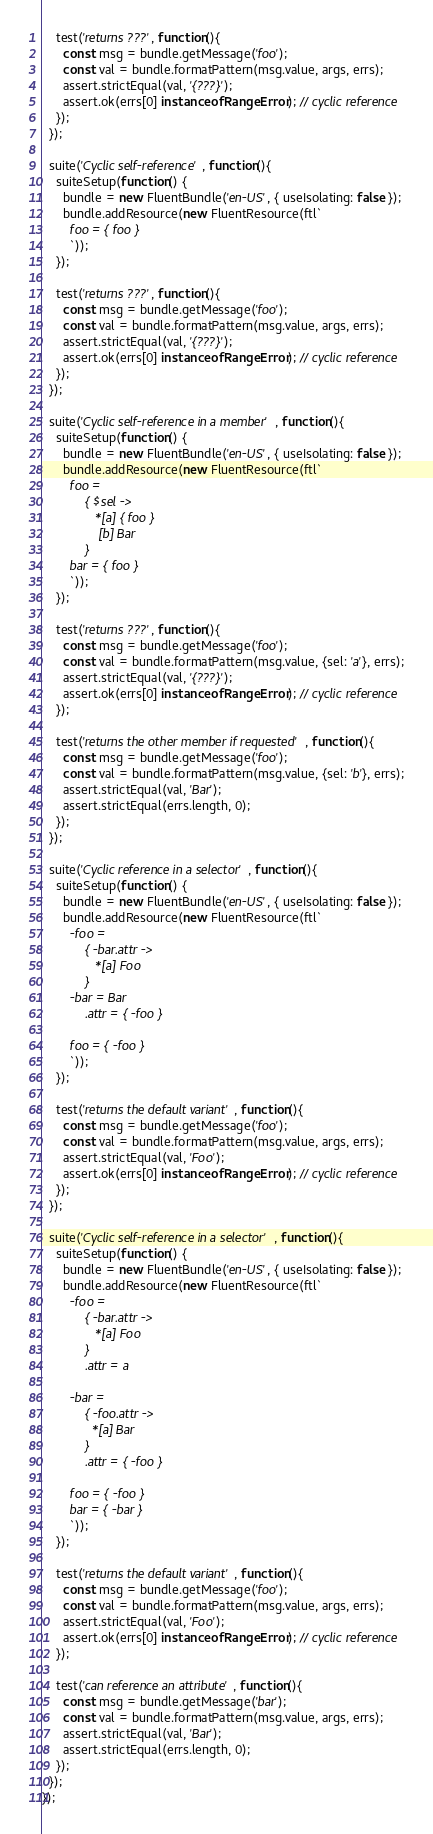<code> <loc_0><loc_0><loc_500><loc_500><_JavaScript_>
    test('returns ???', function(){
      const msg = bundle.getMessage('foo');
      const val = bundle.formatPattern(msg.value, args, errs);
      assert.strictEqual(val, '{???}');
      assert.ok(errs[0] instanceof RangeError); // cyclic reference
    });
  });

  suite('Cyclic self-reference', function(){
    suiteSetup(function() {
      bundle = new FluentBundle('en-US', { useIsolating: false });
      bundle.addResource(new FluentResource(ftl`
        foo = { foo }
        `));
    });

    test('returns ???', function(){
      const msg = bundle.getMessage('foo');
      const val = bundle.formatPattern(msg.value, args, errs);
      assert.strictEqual(val, '{???}');
      assert.ok(errs[0] instanceof RangeError); // cyclic reference
    });
  });

  suite('Cyclic self-reference in a member', function(){
    suiteSetup(function() {
      bundle = new FluentBundle('en-US', { useIsolating: false });
      bundle.addResource(new FluentResource(ftl`
        foo =
            { $sel ->
               *[a] { foo }
                [b] Bar
            }
        bar = { foo }
        `));
    });

    test('returns ???', function(){
      const msg = bundle.getMessage('foo');
      const val = bundle.formatPattern(msg.value, {sel: 'a'}, errs);
      assert.strictEqual(val, '{???}');
      assert.ok(errs[0] instanceof RangeError); // cyclic reference
    });

    test('returns the other member if requested', function(){
      const msg = bundle.getMessage('foo');
      const val = bundle.formatPattern(msg.value, {sel: 'b'}, errs);
      assert.strictEqual(val, 'Bar');
      assert.strictEqual(errs.length, 0);
    });
  });

  suite('Cyclic reference in a selector', function(){
    suiteSetup(function() {
      bundle = new FluentBundle('en-US', { useIsolating: false });
      bundle.addResource(new FluentResource(ftl`
        -foo =
            { -bar.attr ->
               *[a] Foo
            }
        -bar = Bar
            .attr = { -foo }

        foo = { -foo }
        `));
    });

    test('returns the default variant', function(){
      const msg = bundle.getMessage('foo');
      const val = bundle.formatPattern(msg.value, args, errs);
      assert.strictEqual(val, 'Foo');
      assert.ok(errs[0] instanceof RangeError); // cyclic reference
    });
  });

  suite('Cyclic self-reference in a selector', function(){
    suiteSetup(function() {
      bundle = new FluentBundle('en-US', { useIsolating: false });
      bundle.addResource(new FluentResource(ftl`
        -foo =
            { -bar.attr ->
               *[a] Foo
            }
            .attr = a

        -bar =
            { -foo.attr ->
              *[a] Bar
            }
            .attr = { -foo }

        foo = { -foo }
        bar = { -bar }
        `));
    });

    test('returns the default variant', function(){
      const msg = bundle.getMessage('foo');
      const val = bundle.formatPattern(msg.value, args, errs);
      assert.strictEqual(val, 'Foo');
      assert.ok(errs[0] instanceof RangeError); // cyclic reference
    });

    test('can reference an attribute', function(){
      const msg = bundle.getMessage('bar');
      const val = bundle.formatPattern(msg.value, args, errs);
      assert.strictEqual(val, 'Bar');
      assert.strictEqual(errs.length, 0);
    });
  });
});
</code> 